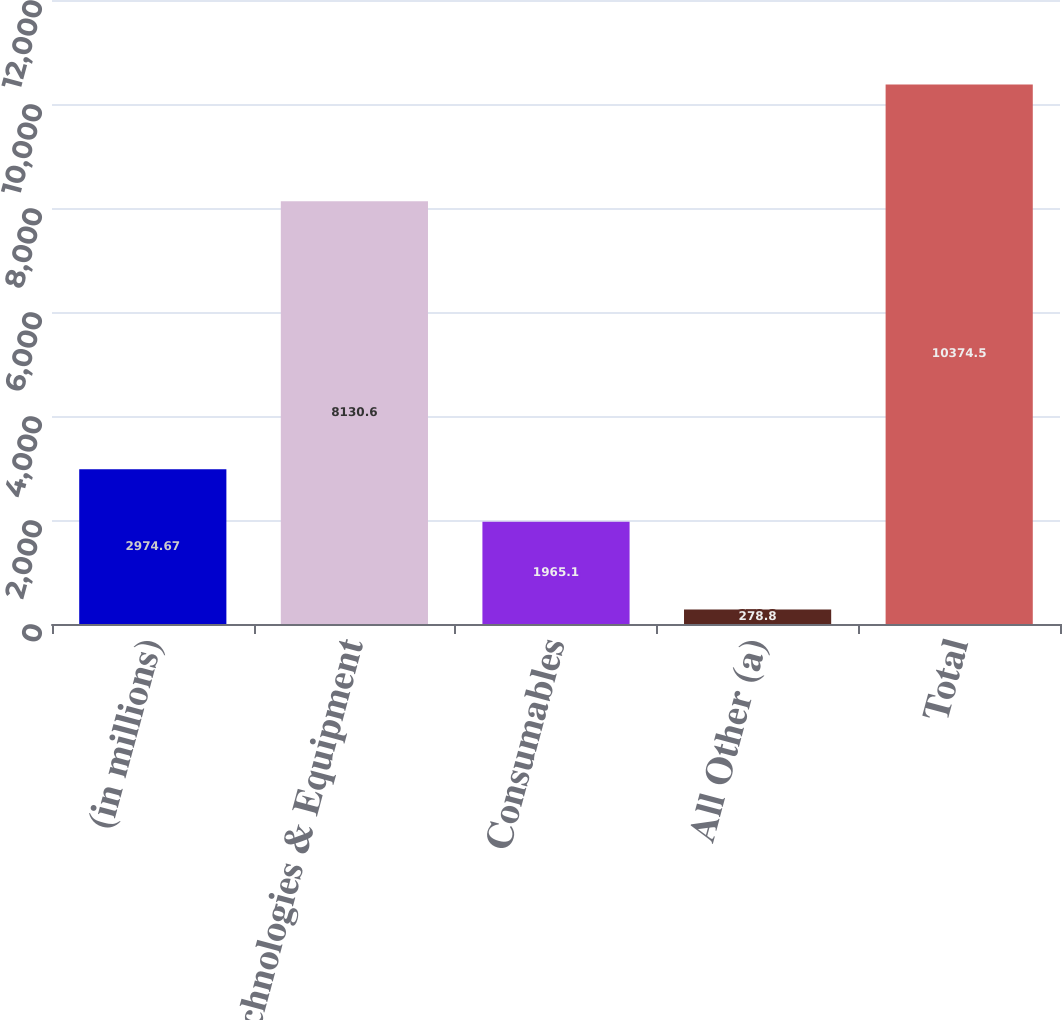<chart> <loc_0><loc_0><loc_500><loc_500><bar_chart><fcel>(in millions)<fcel>Technologies & Equipment<fcel>Consumables<fcel>All Other (a)<fcel>Total<nl><fcel>2974.67<fcel>8130.6<fcel>1965.1<fcel>278.8<fcel>10374.5<nl></chart> 